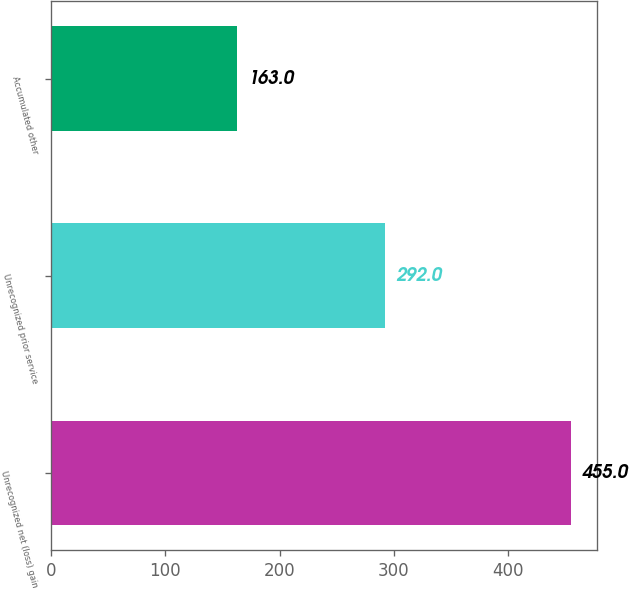<chart> <loc_0><loc_0><loc_500><loc_500><bar_chart><fcel>Unrecognized net (loss) gain<fcel>Unrecognized prior service<fcel>Accumulated other<nl><fcel>455<fcel>292<fcel>163<nl></chart> 